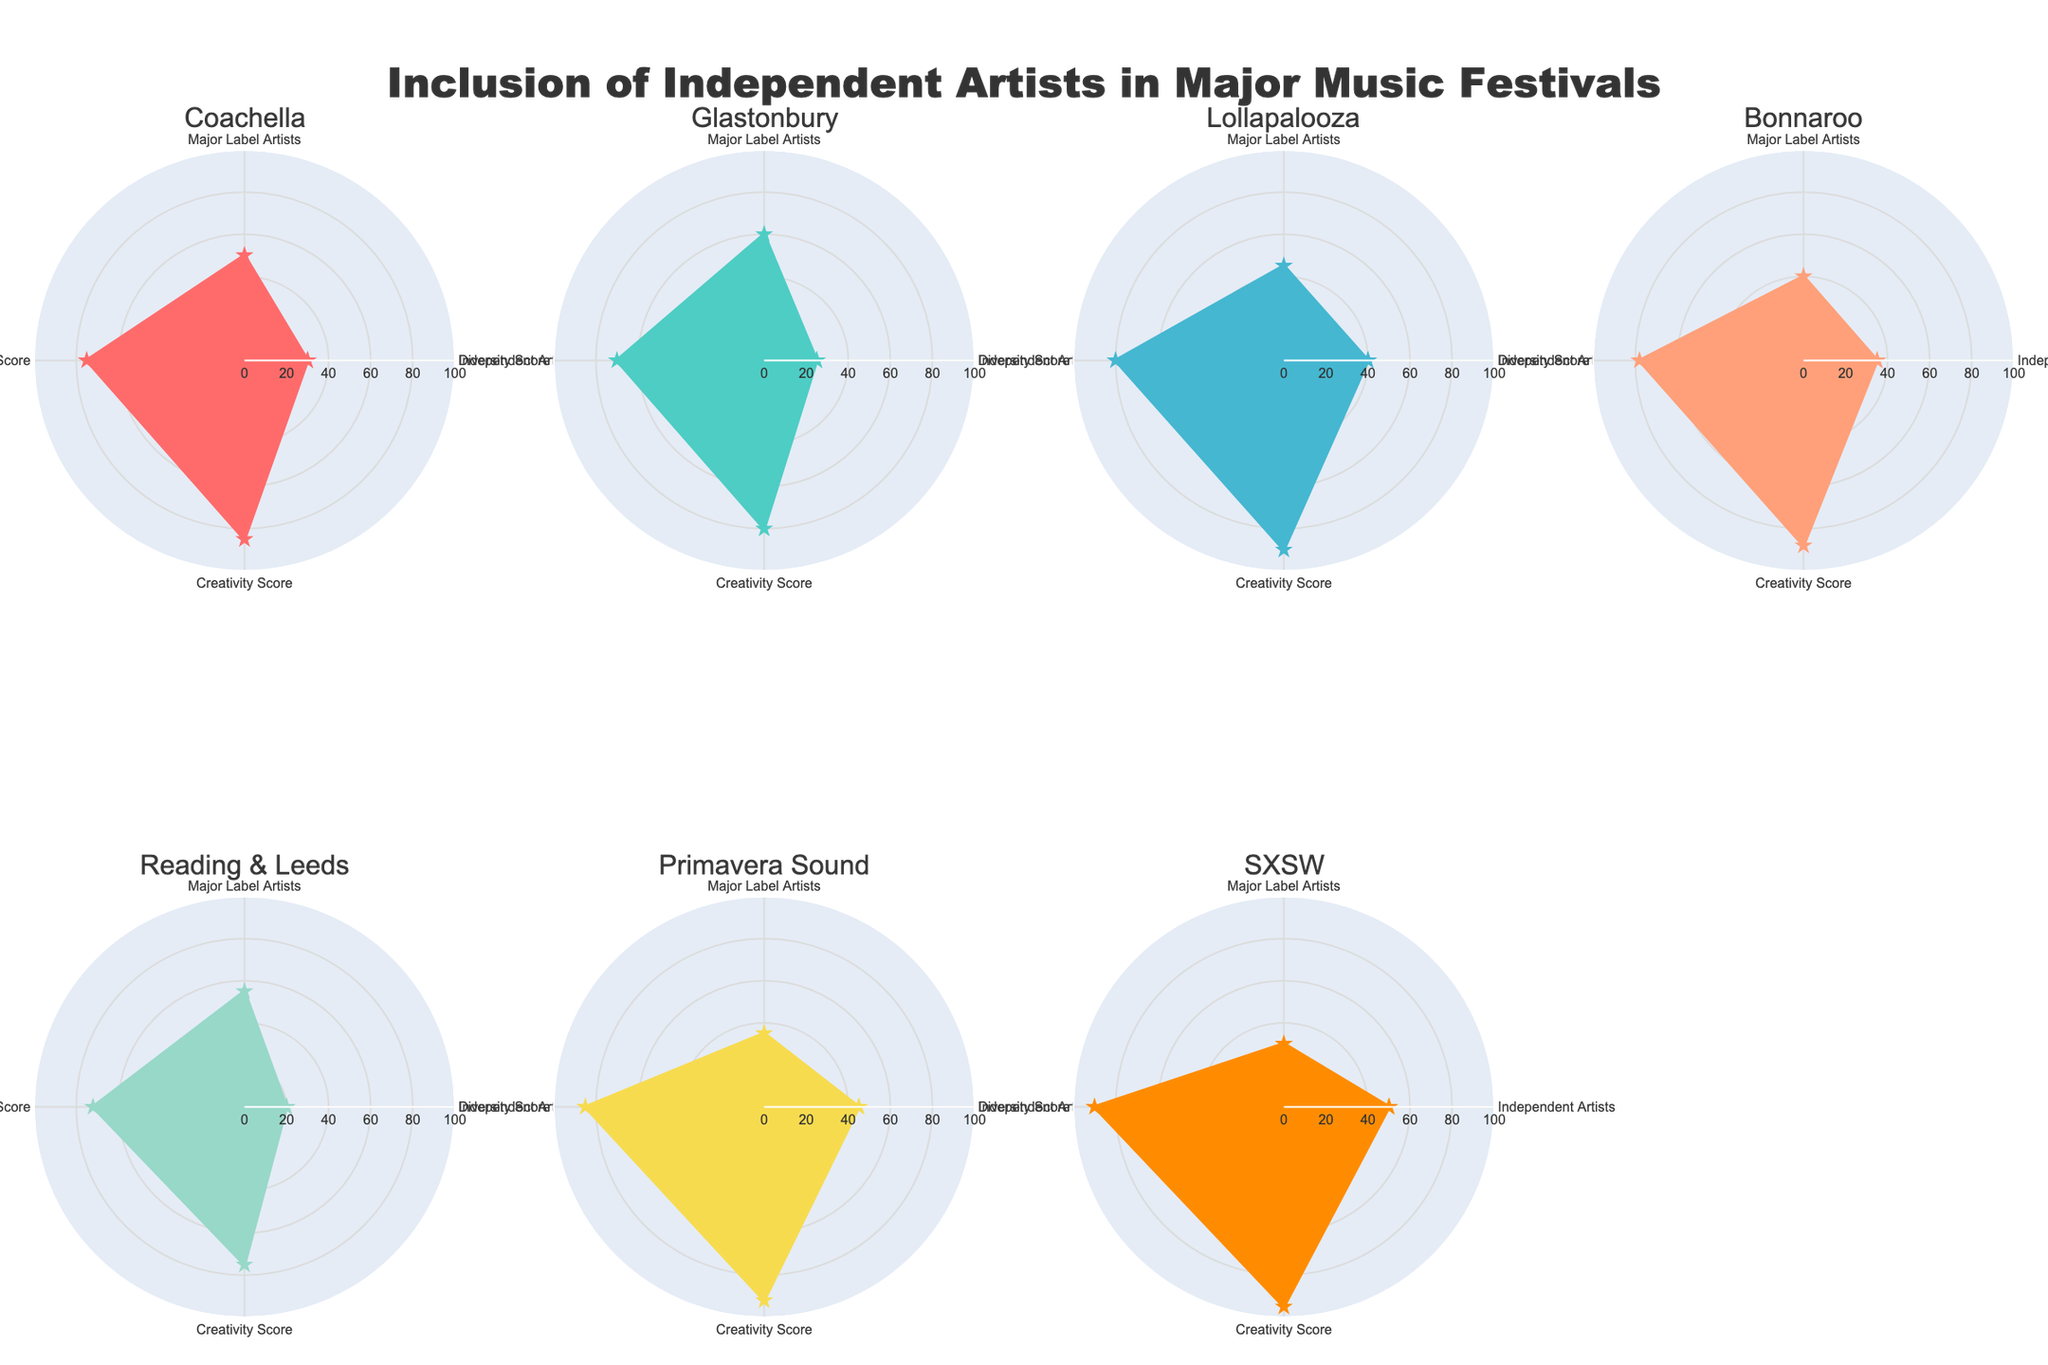How many festivals have more than 40 independent artists performing? There are seven festivals. To find the number of festivals with more than 40 independent artists, look at the 'Independent Artists' data. Coachella has 30, Glastonbury has 25, Lollapalooza has 40, Bonnaroo has 35, Reading & Leeds has 20, Primavera Sound has 45, and SXSW has 50. So, two festivals: Primavera Sound and SXSW, have more than 40 independent artists.
Answer: 2 Which festival has the highest Creativity Score? To determine this, we examine the 'Creativity Score' values. Coachella has 85, Glastonbury has 80, Lollapalooza has 90, Bonnaroo has 88, Reading & Leeds has 75, Primavera Sound has 92, and SXSW has 95. The highest value is 95 for SXSW.
Answer: SXSW Compare the Diversity Scores of Coachella and Glastonbury. Which is higher? Look at the 'Diversity Score' values. Coachella has 75, and Glastonbury has 70. Coachella's score is higher.
Answer: Coachella What is the average number of Major Label Artists performing across all festivals? To find this, we sum the 'Major Label Artists' values and divide by the number of festivals. The values are 50, 60, 45, 40, 55, 35, and 30. Sum: 50 + 60 + 45 + 40 + 55 + 35 + 30 = 315. There are 7 festivals, so the average is 315 / 7 = 45.
Answer: 45 Which festival has the lowest Diversity Score, and what is it? Examine the 'Diversity Score' values. Coachella has 75, Glastonbury has 70, Lollapalooza has 80, Bonnaroo has 78, Reading & Leeds has 72, Primavera Sound has 85, and SXSW has 90. The lowest score is 70 for Glastonbury.
Answer: Glastonbury, 70 Compare the Creativity Score of SXSW and Lollapalooza. By how much does SXSW outperform Lollapalooza? Look at 'Creativity Score' values. SXSW has 95, and Lollapalooza has 90. Subtract 90 from 95 to find the difference, which is 5.
Answer: 5 What is the sum of Independent Artists performing at all festivals? Add the 'Independent Artists' values: 30, 25, 40, 35, 20, 45, 50. Sum: 30 + 25 + 40 + 35 + 20 + 45 + 50 = 245.
Answer: 245 Which festival has the largest number of combined Independent and Major Label Artists? To find this, sum the 'Independent Artists' and 'Major Label Artists' for each festival:
- Coachella: 30 + 50 = 80
- Glastonbury: 25 + 60 = 85
- Lollapalooza: 40 + 45 = 85
- Bonnaroo: 35 + 40 = 75
- Reading & Leeds: 20 + 55 = 75
- Primavera Sound: 45 + 35 = 80
- SXSW: 50 + 30 = 80
The highest value is 85, shared by Glastonbury and Lollapalooza.
Answer: Glastonbury, Lollapalooza What is the average Diversity Score across all festivals? Sum the 'Diversity Score' values and divide by the number of festivals. Scores: 75, 70, 80, 78, 72, 85, 90. Sum: 75 + 70 + 80 + 78 + 72 + 85 + 90 = 550. The average is 550 / 7 ≈ 78.57.
Answer: 78.57 